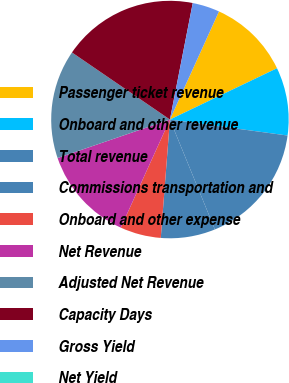Convert chart to OTSL. <chart><loc_0><loc_0><loc_500><loc_500><pie_chart><fcel>Passenger ticket revenue<fcel>Onboard and other revenue<fcel>Total revenue<fcel>Commissions transportation and<fcel>Onboard and other expense<fcel>Net Revenue<fcel>Adjusted Net Revenue<fcel>Capacity Days<fcel>Gross Yield<fcel>Net Yield<nl><fcel>11.11%<fcel>9.26%<fcel>16.67%<fcel>7.41%<fcel>5.56%<fcel>12.96%<fcel>14.81%<fcel>18.52%<fcel>3.7%<fcel>0.0%<nl></chart> 